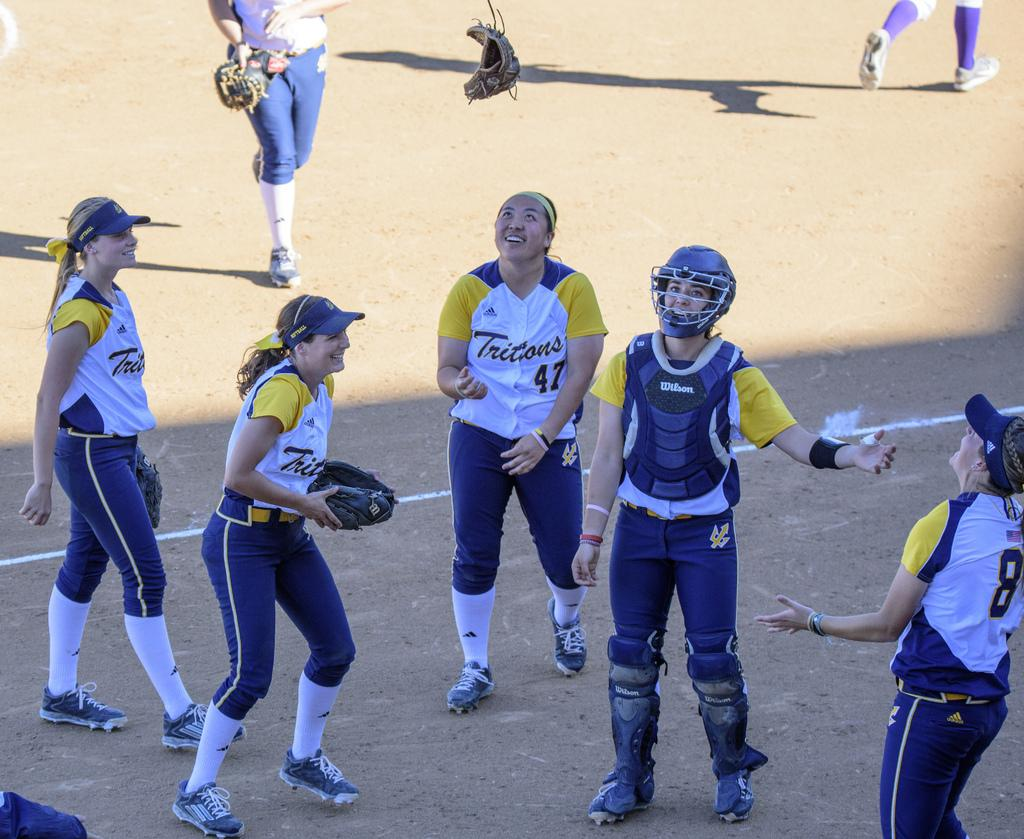<image>
Render a clear and concise summary of the photo. The girl in the yellow and white jersey is wearing number 47 